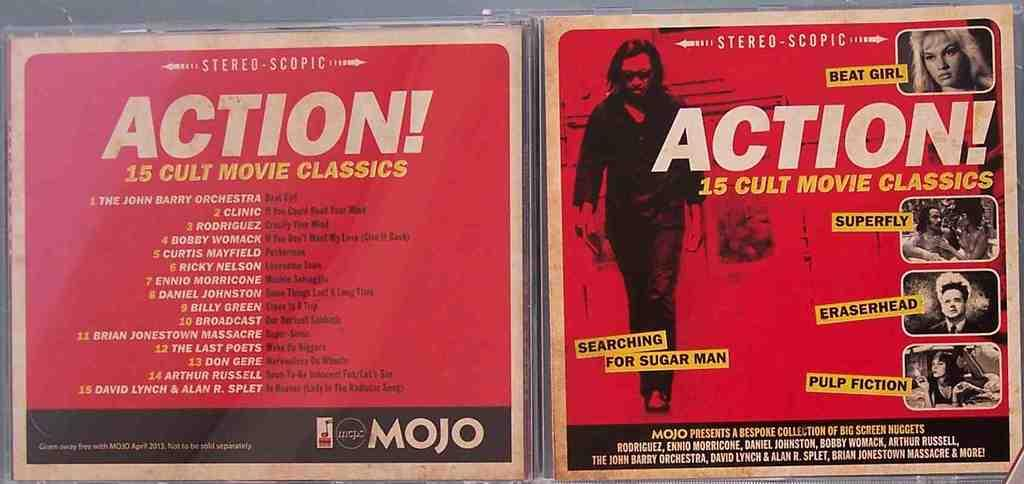<image>
Create a compact narrative representing the image presented. The front and back cover art for compilation album ACTION! 15 CULT MOVIE CLASSICS 